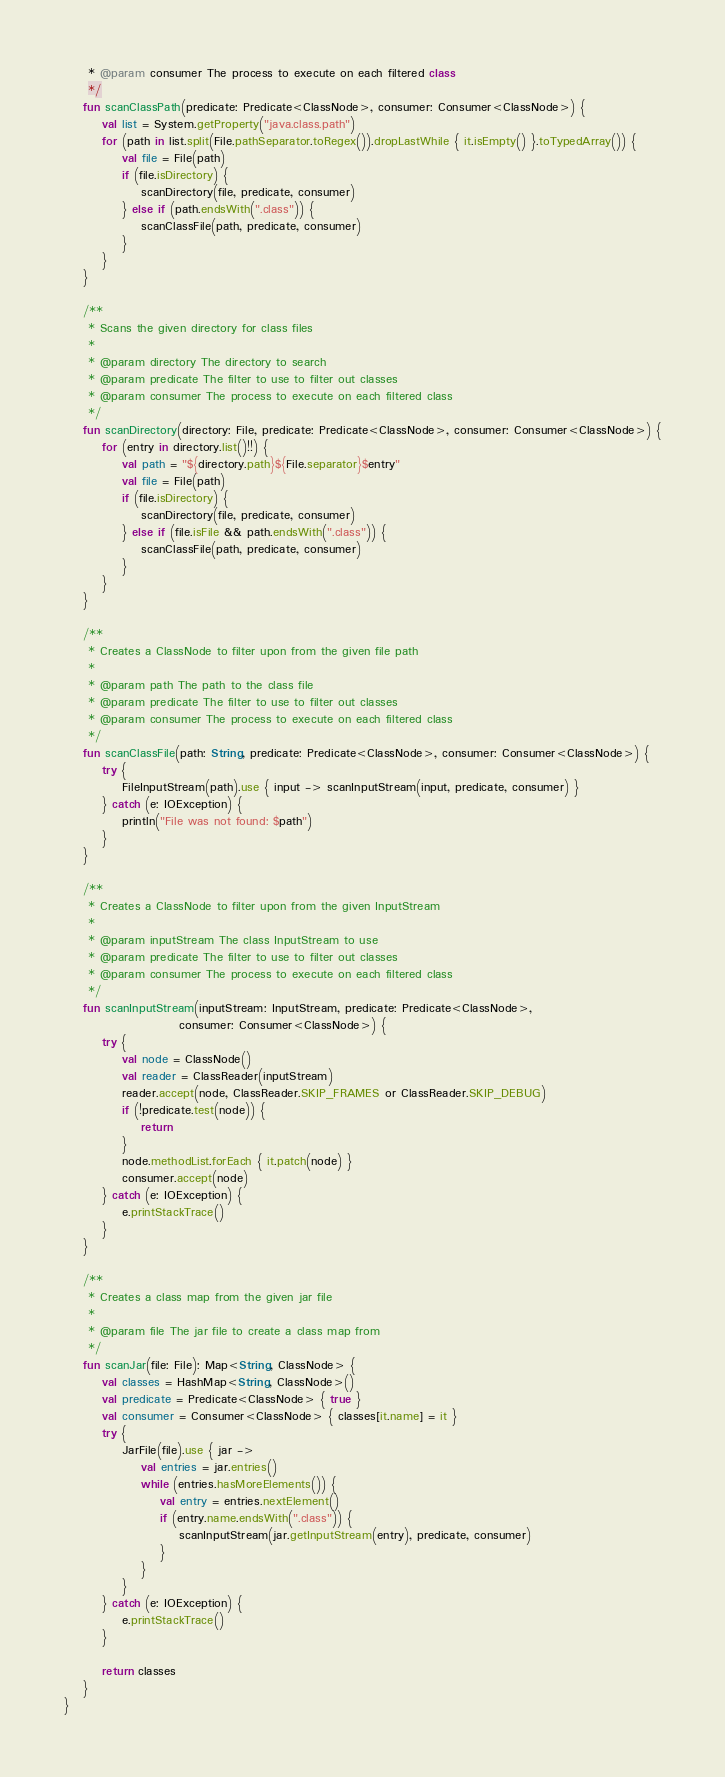Convert code to text. <code><loc_0><loc_0><loc_500><loc_500><_Kotlin_>     * @param consumer The process to execute on each filtered class
     */
    fun scanClassPath(predicate: Predicate<ClassNode>, consumer: Consumer<ClassNode>) {
        val list = System.getProperty("java.class.path")
        for (path in list.split(File.pathSeparator.toRegex()).dropLastWhile { it.isEmpty() }.toTypedArray()) {
            val file = File(path)
            if (file.isDirectory) {
                scanDirectory(file, predicate, consumer)
            } else if (path.endsWith(".class")) {
                scanClassFile(path, predicate, consumer)
            }
        }
    }

    /**
     * Scans the given directory for class files
     *
     * @param directory The directory to search
     * @param predicate The filter to use to filter out classes
     * @param consumer The process to execute on each filtered class
     */
    fun scanDirectory(directory: File, predicate: Predicate<ClassNode>, consumer: Consumer<ClassNode>) {
        for (entry in directory.list()!!) {
            val path = "${directory.path}${File.separator}$entry"
            val file = File(path)
            if (file.isDirectory) {
                scanDirectory(file, predicate, consumer)
            } else if (file.isFile && path.endsWith(".class")) {
                scanClassFile(path, predicate, consumer)
            }
        }
    }

    /**
     * Creates a ClassNode to filter upon from the given file path
     *
     * @param path The path to the class file
     * @param predicate The filter to use to filter out classes
     * @param consumer The process to execute on each filtered class
     */
    fun scanClassFile(path: String, predicate: Predicate<ClassNode>, consumer: Consumer<ClassNode>) {
        try {
            FileInputStream(path).use { input -> scanInputStream(input, predicate, consumer) }
        } catch (e: IOException) {
            println("File was not found: $path")
        }
    }

    /**
     * Creates a ClassNode to filter upon from the given InputStream
     *
     * @param inputStream The class InputStream to use
     * @param predicate The filter to use to filter out classes
     * @param consumer The process to execute on each filtered class
     */
    fun scanInputStream(inputStream: InputStream, predicate: Predicate<ClassNode>,
                        consumer: Consumer<ClassNode>) {
        try {
            val node = ClassNode()
            val reader = ClassReader(inputStream)
            reader.accept(node, ClassReader.SKIP_FRAMES or ClassReader.SKIP_DEBUG)
            if (!predicate.test(node)) {
                return
            }
            node.methodList.forEach { it.patch(node) }
            consumer.accept(node)
        } catch (e: IOException) {
            e.printStackTrace()
        }
    }

    /**
     * Creates a class map from the given jar file
     *
     * @param file The jar file to create a class map from
     */
    fun scanJar(file: File): Map<String, ClassNode> {
        val classes = HashMap<String, ClassNode>()
        val predicate = Predicate<ClassNode> { true }
        val consumer = Consumer<ClassNode> { classes[it.name] = it }
        try {
            JarFile(file).use { jar ->
                val entries = jar.entries()
                while (entries.hasMoreElements()) {
                    val entry = entries.nextElement()
                    if (entry.name.endsWith(".class")) {
                        scanInputStream(jar.getInputStream(entry), predicate, consumer)
                    }
                }
            }
        } catch (e: IOException) {
            e.printStackTrace()
        }

        return classes
    }
}</code> 